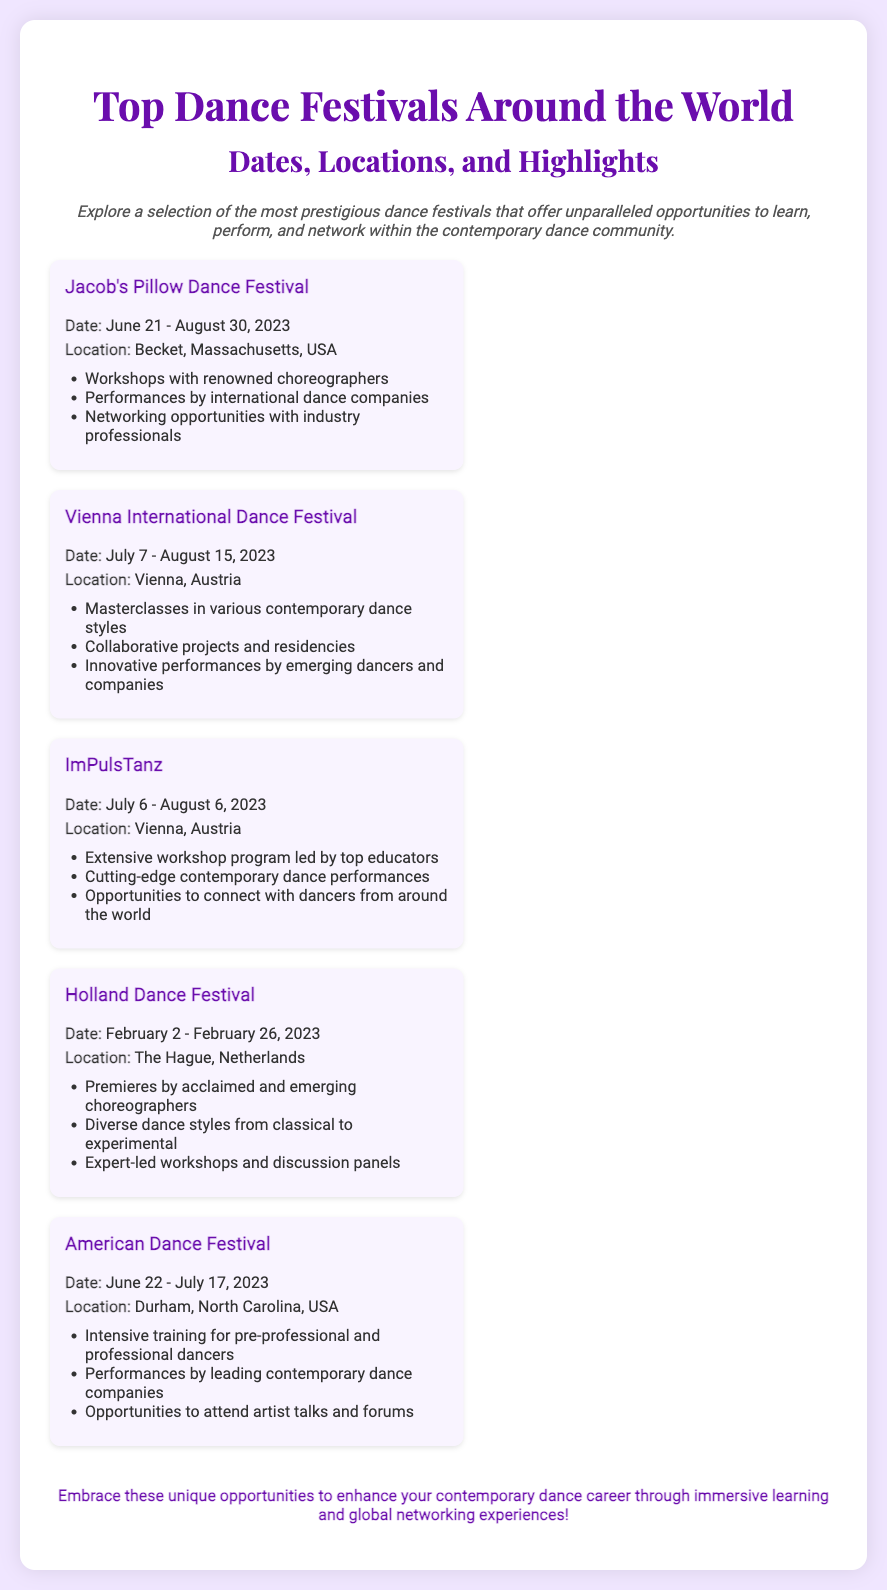what is the location of Jacob's Pillow Dance Festival? The location is stated in the document for Jacob's Pillow Dance Festival, which is Becket, Massachusetts, USA.
Answer: Becket, Massachusetts, USA what are the dates of the Vienna International Dance Festival? The document specifies the dates for the Vienna International Dance Festival, which are July 7 - August 15, 2023.
Answer: July 7 - August 15, 2023 what types of opportunities does the American Dance Festival offer? The document lists opportunities available at the American Dance Festival, including intensive training, performances, and artist talks.
Answer: Intensive training, performances, artist talks which festival takes place in February? The document provides the dates and details of the Holland Dance Festival, which occurs in February.
Answer: Holland Dance Festival how many festivals are listed in the document? The document mentions a total of five dance festivals, which can be counted by reviewing the festival sections.
Answer: Five what do participants gain from the Holland Dance Festival? The document outlines what participants experience at the Holland Dance Festival, which includes premieres and workshops.
Answer: Premieres, workshops which festival includes workshops with renowned choreographers? The document highlights that the Jacob's Pillow Dance Festival features workshops with renowned choreographers.
Answer: Jacob's Pillow Dance Festival what common theme is present in the highlights of each festival? The document's highlights indicate that each festival emphasizes opportunities for learning, performance, and networking.
Answer: Learning, performance, networking 